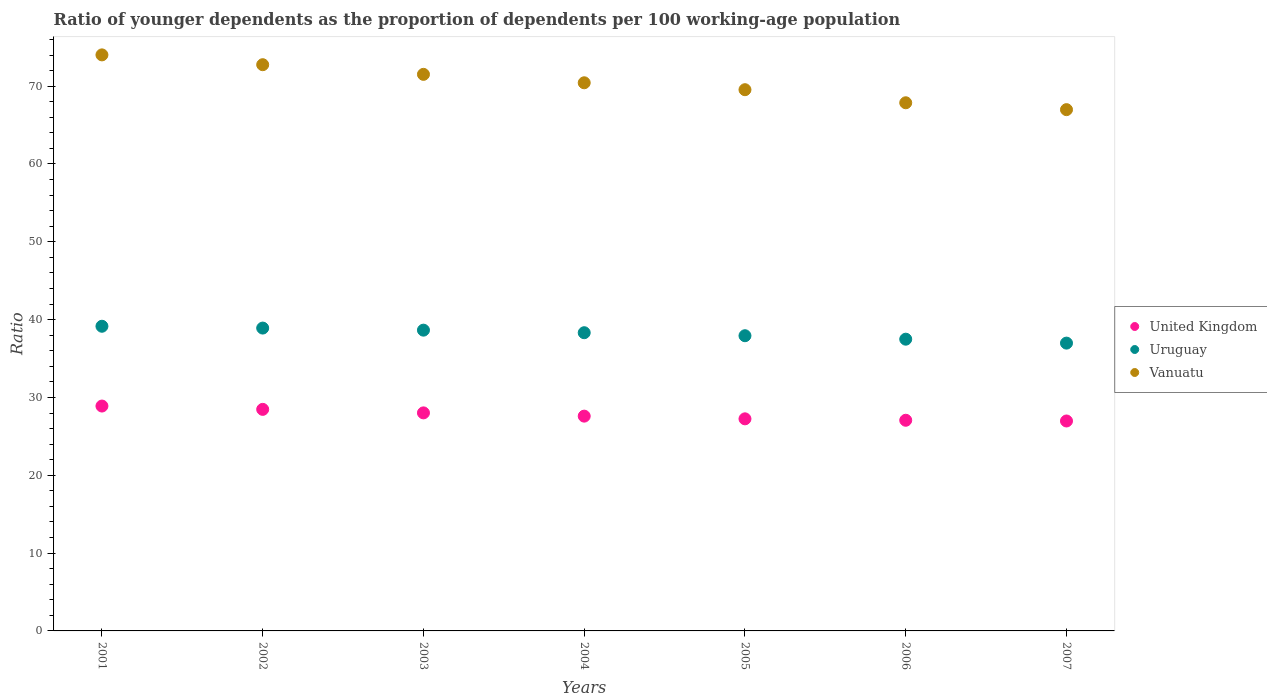How many different coloured dotlines are there?
Offer a very short reply. 3. What is the age dependency ratio(young) in Vanuatu in 2007?
Make the answer very short. 66.98. Across all years, what is the maximum age dependency ratio(young) in Uruguay?
Ensure brevity in your answer.  39.15. Across all years, what is the minimum age dependency ratio(young) in United Kingdom?
Your response must be concise. 26.98. In which year was the age dependency ratio(young) in Vanuatu maximum?
Your answer should be very brief. 2001. In which year was the age dependency ratio(young) in Vanuatu minimum?
Provide a succinct answer. 2007. What is the total age dependency ratio(young) in Vanuatu in the graph?
Your response must be concise. 493.09. What is the difference between the age dependency ratio(young) in Vanuatu in 2002 and that in 2007?
Your answer should be compact. 5.77. What is the difference between the age dependency ratio(young) in Vanuatu in 2004 and the age dependency ratio(young) in Uruguay in 2003?
Make the answer very short. 31.78. What is the average age dependency ratio(young) in Uruguay per year?
Ensure brevity in your answer.  38.2. In the year 2002, what is the difference between the age dependency ratio(young) in Uruguay and age dependency ratio(young) in Vanuatu?
Make the answer very short. -33.84. In how many years, is the age dependency ratio(young) in Uruguay greater than 32?
Offer a very short reply. 7. What is the ratio of the age dependency ratio(young) in Vanuatu in 2004 to that in 2007?
Make the answer very short. 1.05. Is the age dependency ratio(young) in United Kingdom in 2006 less than that in 2007?
Keep it short and to the point. No. What is the difference between the highest and the second highest age dependency ratio(young) in Uruguay?
Your answer should be very brief. 0.23. What is the difference between the highest and the lowest age dependency ratio(young) in Vanuatu?
Offer a terse response. 7.04. Does the age dependency ratio(young) in Uruguay monotonically increase over the years?
Keep it short and to the point. No. Is the age dependency ratio(young) in Vanuatu strictly greater than the age dependency ratio(young) in Uruguay over the years?
Your answer should be very brief. Yes. What is the difference between two consecutive major ticks on the Y-axis?
Make the answer very short. 10. Does the graph contain grids?
Offer a terse response. No. How are the legend labels stacked?
Ensure brevity in your answer.  Vertical. What is the title of the graph?
Provide a succinct answer. Ratio of younger dependents as the proportion of dependents per 100 working-age population. What is the label or title of the Y-axis?
Keep it short and to the point. Ratio. What is the Ratio in United Kingdom in 2001?
Give a very brief answer. 28.89. What is the Ratio in Uruguay in 2001?
Provide a short and direct response. 39.15. What is the Ratio in Vanuatu in 2001?
Provide a short and direct response. 74.02. What is the Ratio of United Kingdom in 2002?
Make the answer very short. 28.47. What is the Ratio of Uruguay in 2002?
Keep it short and to the point. 38.91. What is the Ratio of Vanuatu in 2002?
Your answer should be very brief. 72.75. What is the Ratio of United Kingdom in 2003?
Ensure brevity in your answer.  28.02. What is the Ratio of Uruguay in 2003?
Provide a succinct answer. 38.65. What is the Ratio in Vanuatu in 2003?
Provide a succinct answer. 71.51. What is the Ratio in United Kingdom in 2004?
Provide a succinct answer. 27.6. What is the Ratio of Uruguay in 2004?
Ensure brevity in your answer.  38.32. What is the Ratio of Vanuatu in 2004?
Provide a short and direct response. 70.43. What is the Ratio in United Kingdom in 2005?
Provide a succinct answer. 27.25. What is the Ratio of Uruguay in 2005?
Your answer should be very brief. 37.93. What is the Ratio in Vanuatu in 2005?
Offer a terse response. 69.54. What is the Ratio in United Kingdom in 2006?
Make the answer very short. 27.07. What is the Ratio in Uruguay in 2006?
Your answer should be very brief. 37.49. What is the Ratio of Vanuatu in 2006?
Provide a succinct answer. 67.86. What is the Ratio in United Kingdom in 2007?
Provide a succinct answer. 26.98. What is the Ratio in Uruguay in 2007?
Your response must be concise. 36.98. What is the Ratio in Vanuatu in 2007?
Your response must be concise. 66.98. Across all years, what is the maximum Ratio of United Kingdom?
Keep it short and to the point. 28.89. Across all years, what is the maximum Ratio in Uruguay?
Make the answer very short. 39.15. Across all years, what is the maximum Ratio of Vanuatu?
Provide a succinct answer. 74.02. Across all years, what is the minimum Ratio in United Kingdom?
Offer a terse response. 26.98. Across all years, what is the minimum Ratio in Uruguay?
Make the answer very short. 36.98. Across all years, what is the minimum Ratio in Vanuatu?
Your response must be concise. 66.98. What is the total Ratio in United Kingdom in the graph?
Give a very brief answer. 194.27. What is the total Ratio in Uruguay in the graph?
Offer a very short reply. 267.42. What is the total Ratio in Vanuatu in the graph?
Offer a terse response. 493.09. What is the difference between the Ratio of United Kingdom in 2001 and that in 2002?
Your answer should be compact. 0.43. What is the difference between the Ratio in Uruguay in 2001 and that in 2002?
Your response must be concise. 0.23. What is the difference between the Ratio in Vanuatu in 2001 and that in 2002?
Offer a terse response. 1.26. What is the difference between the Ratio of United Kingdom in 2001 and that in 2003?
Give a very brief answer. 0.88. What is the difference between the Ratio of Uruguay in 2001 and that in 2003?
Ensure brevity in your answer.  0.5. What is the difference between the Ratio in Vanuatu in 2001 and that in 2003?
Provide a succinct answer. 2.5. What is the difference between the Ratio of United Kingdom in 2001 and that in 2004?
Your answer should be very brief. 1.3. What is the difference between the Ratio in Uruguay in 2001 and that in 2004?
Your response must be concise. 0.83. What is the difference between the Ratio of Vanuatu in 2001 and that in 2004?
Ensure brevity in your answer.  3.59. What is the difference between the Ratio of United Kingdom in 2001 and that in 2005?
Make the answer very short. 1.64. What is the difference between the Ratio in Uruguay in 2001 and that in 2005?
Make the answer very short. 1.22. What is the difference between the Ratio of Vanuatu in 2001 and that in 2005?
Your response must be concise. 4.47. What is the difference between the Ratio in United Kingdom in 2001 and that in 2006?
Keep it short and to the point. 1.83. What is the difference between the Ratio of Uruguay in 2001 and that in 2006?
Your response must be concise. 1.66. What is the difference between the Ratio in Vanuatu in 2001 and that in 2006?
Ensure brevity in your answer.  6.15. What is the difference between the Ratio in United Kingdom in 2001 and that in 2007?
Offer a terse response. 1.92. What is the difference between the Ratio of Uruguay in 2001 and that in 2007?
Your answer should be compact. 2.17. What is the difference between the Ratio of Vanuatu in 2001 and that in 2007?
Your answer should be compact. 7.04. What is the difference between the Ratio in United Kingdom in 2002 and that in 2003?
Ensure brevity in your answer.  0.45. What is the difference between the Ratio in Uruguay in 2002 and that in 2003?
Your answer should be compact. 0.27. What is the difference between the Ratio of Vanuatu in 2002 and that in 2003?
Your response must be concise. 1.24. What is the difference between the Ratio in United Kingdom in 2002 and that in 2004?
Give a very brief answer. 0.87. What is the difference between the Ratio of Uruguay in 2002 and that in 2004?
Give a very brief answer. 0.6. What is the difference between the Ratio in Vanuatu in 2002 and that in 2004?
Give a very brief answer. 2.32. What is the difference between the Ratio of United Kingdom in 2002 and that in 2005?
Your answer should be compact. 1.22. What is the difference between the Ratio of Uruguay in 2002 and that in 2005?
Your response must be concise. 0.98. What is the difference between the Ratio in Vanuatu in 2002 and that in 2005?
Ensure brevity in your answer.  3.21. What is the difference between the Ratio of United Kingdom in 2002 and that in 2006?
Provide a succinct answer. 1.4. What is the difference between the Ratio of Uruguay in 2002 and that in 2006?
Give a very brief answer. 1.43. What is the difference between the Ratio of Vanuatu in 2002 and that in 2006?
Offer a very short reply. 4.89. What is the difference between the Ratio of United Kingdom in 2002 and that in 2007?
Ensure brevity in your answer.  1.49. What is the difference between the Ratio of Uruguay in 2002 and that in 2007?
Provide a short and direct response. 1.93. What is the difference between the Ratio of Vanuatu in 2002 and that in 2007?
Keep it short and to the point. 5.77. What is the difference between the Ratio in United Kingdom in 2003 and that in 2004?
Provide a succinct answer. 0.42. What is the difference between the Ratio of Uruguay in 2003 and that in 2004?
Offer a very short reply. 0.33. What is the difference between the Ratio of Vanuatu in 2003 and that in 2004?
Your answer should be compact. 1.08. What is the difference between the Ratio of United Kingdom in 2003 and that in 2005?
Provide a succinct answer. 0.77. What is the difference between the Ratio of Uruguay in 2003 and that in 2005?
Provide a short and direct response. 0.72. What is the difference between the Ratio of Vanuatu in 2003 and that in 2005?
Offer a very short reply. 1.97. What is the difference between the Ratio in United Kingdom in 2003 and that in 2006?
Keep it short and to the point. 0.95. What is the difference between the Ratio in Uruguay in 2003 and that in 2006?
Give a very brief answer. 1.16. What is the difference between the Ratio of Vanuatu in 2003 and that in 2006?
Provide a succinct answer. 3.65. What is the difference between the Ratio of United Kingdom in 2003 and that in 2007?
Provide a succinct answer. 1.04. What is the difference between the Ratio of Uruguay in 2003 and that in 2007?
Your answer should be compact. 1.67. What is the difference between the Ratio of Vanuatu in 2003 and that in 2007?
Your response must be concise. 4.53. What is the difference between the Ratio of United Kingdom in 2004 and that in 2005?
Offer a terse response. 0.35. What is the difference between the Ratio in Uruguay in 2004 and that in 2005?
Offer a very short reply. 0.39. What is the difference between the Ratio of Vanuatu in 2004 and that in 2005?
Your response must be concise. 0.89. What is the difference between the Ratio in United Kingdom in 2004 and that in 2006?
Give a very brief answer. 0.53. What is the difference between the Ratio in Uruguay in 2004 and that in 2006?
Keep it short and to the point. 0.83. What is the difference between the Ratio of Vanuatu in 2004 and that in 2006?
Provide a succinct answer. 2.57. What is the difference between the Ratio in United Kingdom in 2004 and that in 2007?
Your answer should be compact. 0.62. What is the difference between the Ratio in Uruguay in 2004 and that in 2007?
Offer a very short reply. 1.34. What is the difference between the Ratio in Vanuatu in 2004 and that in 2007?
Ensure brevity in your answer.  3.45. What is the difference between the Ratio of United Kingdom in 2005 and that in 2006?
Offer a very short reply. 0.18. What is the difference between the Ratio of Uruguay in 2005 and that in 2006?
Keep it short and to the point. 0.45. What is the difference between the Ratio of Vanuatu in 2005 and that in 2006?
Give a very brief answer. 1.68. What is the difference between the Ratio in United Kingdom in 2005 and that in 2007?
Your response must be concise. 0.28. What is the difference between the Ratio of Uruguay in 2005 and that in 2007?
Your response must be concise. 0.95. What is the difference between the Ratio in Vanuatu in 2005 and that in 2007?
Your response must be concise. 2.56. What is the difference between the Ratio in United Kingdom in 2006 and that in 2007?
Ensure brevity in your answer.  0.09. What is the difference between the Ratio in Uruguay in 2006 and that in 2007?
Provide a short and direct response. 0.51. What is the difference between the Ratio of Vanuatu in 2006 and that in 2007?
Provide a succinct answer. 0.88. What is the difference between the Ratio of United Kingdom in 2001 and the Ratio of Uruguay in 2002?
Your answer should be very brief. -10.02. What is the difference between the Ratio of United Kingdom in 2001 and the Ratio of Vanuatu in 2002?
Offer a terse response. -43.86. What is the difference between the Ratio in Uruguay in 2001 and the Ratio in Vanuatu in 2002?
Your answer should be very brief. -33.61. What is the difference between the Ratio in United Kingdom in 2001 and the Ratio in Uruguay in 2003?
Provide a short and direct response. -9.75. What is the difference between the Ratio in United Kingdom in 2001 and the Ratio in Vanuatu in 2003?
Offer a very short reply. -42.62. What is the difference between the Ratio of Uruguay in 2001 and the Ratio of Vanuatu in 2003?
Offer a terse response. -32.37. What is the difference between the Ratio in United Kingdom in 2001 and the Ratio in Uruguay in 2004?
Offer a very short reply. -9.42. What is the difference between the Ratio in United Kingdom in 2001 and the Ratio in Vanuatu in 2004?
Your response must be concise. -41.54. What is the difference between the Ratio in Uruguay in 2001 and the Ratio in Vanuatu in 2004?
Make the answer very short. -31.28. What is the difference between the Ratio in United Kingdom in 2001 and the Ratio in Uruguay in 2005?
Your answer should be very brief. -9.04. What is the difference between the Ratio of United Kingdom in 2001 and the Ratio of Vanuatu in 2005?
Provide a succinct answer. -40.65. What is the difference between the Ratio of Uruguay in 2001 and the Ratio of Vanuatu in 2005?
Offer a very short reply. -30.4. What is the difference between the Ratio in United Kingdom in 2001 and the Ratio in Uruguay in 2006?
Ensure brevity in your answer.  -8.59. What is the difference between the Ratio in United Kingdom in 2001 and the Ratio in Vanuatu in 2006?
Your answer should be very brief. -38.97. What is the difference between the Ratio in Uruguay in 2001 and the Ratio in Vanuatu in 2006?
Provide a succinct answer. -28.72. What is the difference between the Ratio of United Kingdom in 2001 and the Ratio of Uruguay in 2007?
Offer a terse response. -8.09. What is the difference between the Ratio of United Kingdom in 2001 and the Ratio of Vanuatu in 2007?
Your response must be concise. -38.08. What is the difference between the Ratio in Uruguay in 2001 and the Ratio in Vanuatu in 2007?
Provide a succinct answer. -27.83. What is the difference between the Ratio in United Kingdom in 2002 and the Ratio in Uruguay in 2003?
Offer a very short reply. -10.18. What is the difference between the Ratio in United Kingdom in 2002 and the Ratio in Vanuatu in 2003?
Offer a very short reply. -43.05. What is the difference between the Ratio of Uruguay in 2002 and the Ratio of Vanuatu in 2003?
Give a very brief answer. -32.6. What is the difference between the Ratio of United Kingdom in 2002 and the Ratio of Uruguay in 2004?
Give a very brief answer. -9.85. What is the difference between the Ratio of United Kingdom in 2002 and the Ratio of Vanuatu in 2004?
Make the answer very short. -41.96. What is the difference between the Ratio in Uruguay in 2002 and the Ratio in Vanuatu in 2004?
Your answer should be very brief. -31.52. What is the difference between the Ratio in United Kingdom in 2002 and the Ratio in Uruguay in 2005?
Ensure brevity in your answer.  -9.46. What is the difference between the Ratio of United Kingdom in 2002 and the Ratio of Vanuatu in 2005?
Offer a terse response. -41.07. What is the difference between the Ratio in Uruguay in 2002 and the Ratio in Vanuatu in 2005?
Your answer should be compact. -30.63. What is the difference between the Ratio of United Kingdom in 2002 and the Ratio of Uruguay in 2006?
Offer a terse response. -9.02. What is the difference between the Ratio of United Kingdom in 2002 and the Ratio of Vanuatu in 2006?
Give a very brief answer. -39.39. What is the difference between the Ratio of Uruguay in 2002 and the Ratio of Vanuatu in 2006?
Make the answer very short. -28.95. What is the difference between the Ratio of United Kingdom in 2002 and the Ratio of Uruguay in 2007?
Offer a very short reply. -8.51. What is the difference between the Ratio in United Kingdom in 2002 and the Ratio in Vanuatu in 2007?
Your answer should be compact. -38.51. What is the difference between the Ratio in Uruguay in 2002 and the Ratio in Vanuatu in 2007?
Provide a short and direct response. -28.07. What is the difference between the Ratio in United Kingdom in 2003 and the Ratio in Uruguay in 2004?
Your answer should be very brief. -10.3. What is the difference between the Ratio in United Kingdom in 2003 and the Ratio in Vanuatu in 2004?
Make the answer very short. -42.41. What is the difference between the Ratio in Uruguay in 2003 and the Ratio in Vanuatu in 2004?
Ensure brevity in your answer.  -31.78. What is the difference between the Ratio of United Kingdom in 2003 and the Ratio of Uruguay in 2005?
Your answer should be compact. -9.91. What is the difference between the Ratio of United Kingdom in 2003 and the Ratio of Vanuatu in 2005?
Offer a very short reply. -41.53. What is the difference between the Ratio in Uruguay in 2003 and the Ratio in Vanuatu in 2005?
Offer a terse response. -30.9. What is the difference between the Ratio in United Kingdom in 2003 and the Ratio in Uruguay in 2006?
Offer a very short reply. -9.47. What is the difference between the Ratio of United Kingdom in 2003 and the Ratio of Vanuatu in 2006?
Give a very brief answer. -39.85. What is the difference between the Ratio of Uruguay in 2003 and the Ratio of Vanuatu in 2006?
Offer a terse response. -29.22. What is the difference between the Ratio in United Kingdom in 2003 and the Ratio in Uruguay in 2007?
Provide a succinct answer. -8.96. What is the difference between the Ratio in United Kingdom in 2003 and the Ratio in Vanuatu in 2007?
Give a very brief answer. -38.96. What is the difference between the Ratio in Uruguay in 2003 and the Ratio in Vanuatu in 2007?
Your answer should be compact. -28.33. What is the difference between the Ratio of United Kingdom in 2004 and the Ratio of Uruguay in 2005?
Offer a very short reply. -10.33. What is the difference between the Ratio of United Kingdom in 2004 and the Ratio of Vanuatu in 2005?
Ensure brevity in your answer.  -41.94. What is the difference between the Ratio of Uruguay in 2004 and the Ratio of Vanuatu in 2005?
Offer a very short reply. -31.23. What is the difference between the Ratio of United Kingdom in 2004 and the Ratio of Uruguay in 2006?
Ensure brevity in your answer.  -9.89. What is the difference between the Ratio of United Kingdom in 2004 and the Ratio of Vanuatu in 2006?
Provide a short and direct response. -40.26. What is the difference between the Ratio of Uruguay in 2004 and the Ratio of Vanuatu in 2006?
Offer a very short reply. -29.55. What is the difference between the Ratio in United Kingdom in 2004 and the Ratio in Uruguay in 2007?
Offer a very short reply. -9.38. What is the difference between the Ratio of United Kingdom in 2004 and the Ratio of Vanuatu in 2007?
Make the answer very short. -39.38. What is the difference between the Ratio in Uruguay in 2004 and the Ratio in Vanuatu in 2007?
Keep it short and to the point. -28.66. What is the difference between the Ratio of United Kingdom in 2005 and the Ratio of Uruguay in 2006?
Offer a very short reply. -10.23. What is the difference between the Ratio in United Kingdom in 2005 and the Ratio in Vanuatu in 2006?
Provide a short and direct response. -40.61. What is the difference between the Ratio in Uruguay in 2005 and the Ratio in Vanuatu in 2006?
Offer a terse response. -29.93. What is the difference between the Ratio of United Kingdom in 2005 and the Ratio of Uruguay in 2007?
Keep it short and to the point. -9.73. What is the difference between the Ratio in United Kingdom in 2005 and the Ratio in Vanuatu in 2007?
Provide a short and direct response. -39.73. What is the difference between the Ratio in Uruguay in 2005 and the Ratio in Vanuatu in 2007?
Your answer should be compact. -29.05. What is the difference between the Ratio of United Kingdom in 2006 and the Ratio of Uruguay in 2007?
Your answer should be compact. -9.91. What is the difference between the Ratio of United Kingdom in 2006 and the Ratio of Vanuatu in 2007?
Keep it short and to the point. -39.91. What is the difference between the Ratio of Uruguay in 2006 and the Ratio of Vanuatu in 2007?
Provide a short and direct response. -29.49. What is the average Ratio in United Kingdom per year?
Provide a short and direct response. 27.75. What is the average Ratio in Uruguay per year?
Provide a succinct answer. 38.2. What is the average Ratio of Vanuatu per year?
Your answer should be compact. 70.44. In the year 2001, what is the difference between the Ratio in United Kingdom and Ratio in Uruguay?
Your answer should be very brief. -10.25. In the year 2001, what is the difference between the Ratio of United Kingdom and Ratio of Vanuatu?
Make the answer very short. -45.12. In the year 2001, what is the difference between the Ratio in Uruguay and Ratio in Vanuatu?
Your answer should be compact. -34.87. In the year 2002, what is the difference between the Ratio in United Kingdom and Ratio in Uruguay?
Make the answer very short. -10.45. In the year 2002, what is the difference between the Ratio of United Kingdom and Ratio of Vanuatu?
Provide a short and direct response. -44.29. In the year 2002, what is the difference between the Ratio in Uruguay and Ratio in Vanuatu?
Make the answer very short. -33.84. In the year 2003, what is the difference between the Ratio of United Kingdom and Ratio of Uruguay?
Provide a succinct answer. -10.63. In the year 2003, what is the difference between the Ratio of United Kingdom and Ratio of Vanuatu?
Offer a very short reply. -43.5. In the year 2003, what is the difference between the Ratio of Uruguay and Ratio of Vanuatu?
Your response must be concise. -32.87. In the year 2004, what is the difference between the Ratio of United Kingdom and Ratio of Uruguay?
Ensure brevity in your answer.  -10.72. In the year 2004, what is the difference between the Ratio of United Kingdom and Ratio of Vanuatu?
Your answer should be compact. -42.83. In the year 2004, what is the difference between the Ratio in Uruguay and Ratio in Vanuatu?
Give a very brief answer. -32.11. In the year 2005, what is the difference between the Ratio of United Kingdom and Ratio of Uruguay?
Give a very brief answer. -10.68. In the year 2005, what is the difference between the Ratio of United Kingdom and Ratio of Vanuatu?
Provide a succinct answer. -42.29. In the year 2005, what is the difference between the Ratio in Uruguay and Ratio in Vanuatu?
Keep it short and to the point. -31.61. In the year 2006, what is the difference between the Ratio in United Kingdom and Ratio in Uruguay?
Offer a terse response. -10.42. In the year 2006, what is the difference between the Ratio in United Kingdom and Ratio in Vanuatu?
Your answer should be very brief. -40.79. In the year 2006, what is the difference between the Ratio in Uruguay and Ratio in Vanuatu?
Provide a succinct answer. -30.38. In the year 2007, what is the difference between the Ratio of United Kingdom and Ratio of Uruguay?
Keep it short and to the point. -10.01. In the year 2007, what is the difference between the Ratio in United Kingdom and Ratio in Vanuatu?
Your response must be concise. -40. In the year 2007, what is the difference between the Ratio in Uruguay and Ratio in Vanuatu?
Provide a short and direct response. -30. What is the ratio of the Ratio in Uruguay in 2001 to that in 2002?
Keep it short and to the point. 1.01. What is the ratio of the Ratio in Vanuatu in 2001 to that in 2002?
Ensure brevity in your answer.  1.02. What is the ratio of the Ratio in United Kingdom in 2001 to that in 2003?
Keep it short and to the point. 1.03. What is the ratio of the Ratio of Uruguay in 2001 to that in 2003?
Your answer should be compact. 1.01. What is the ratio of the Ratio in Vanuatu in 2001 to that in 2003?
Give a very brief answer. 1.03. What is the ratio of the Ratio of United Kingdom in 2001 to that in 2004?
Ensure brevity in your answer.  1.05. What is the ratio of the Ratio of Uruguay in 2001 to that in 2004?
Provide a short and direct response. 1.02. What is the ratio of the Ratio in Vanuatu in 2001 to that in 2004?
Ensure brevity in your answer.  1.05. What is the ratio of the Ratio in United Kingdom in 2001 to that in 2005?
Keep it short and to the point. 1.06. What is the ratio of the Ratio of Uruguay in 2001 to that in 2005?
Give a very brief answer. 1.03. What is the ratio of the Ratio in Vanuatu in 2001 to that in 2005?
Make the answer very short. 1.06. What is the ratio of the Ratio of United Kingdom in 2001 to that in 2006?
Ensure brevity in your answer.  1.07. What is the ratio of the Ratio of Uruguay in 2001 to that in 2006?
Ensure brevity in your answer.  1.04. What is the ratio of the Ratio in Vanuatu in 2001 to that in 2006?
Your response must be concise. 1.09. What is the ratio of the Ratio of United Kingdom in 2001 to that in 2007?
Your response must be concise. 1.07. What is the ratio of the Ratio of Uruguay in 2001 to that in 2007?
Ensure brevity in your answer.  1.06. What is the ratio of the Ratio of Vanuatu in 2001 to that in 2007?
Provide a succinct answer. 1.11. What is the ratio of the Ratio in United Kingdom in 2002 to that in 2003?
Your answer should be compact. 1.02. What is the ratio of the Ratio in Uruguay in 2002 to that in 2003?
Provide a short and direct response. 1.01. What is the ratio of the Ratio in Vanuatu in 2002 to that in 2003?
Your response must be concise. 1.02. What is the ratio of the Ratio in United Kingdom in 2002 to that in 2004?
Ensure brevity in your answer.  1.03. What is the ratio of the Ratio of Uruguay in 2002 to that in 2004?
Your answer should be very brief. 1.02. What is the ratio of the Ratio in Vanuatu in 2002 to that in 2004?
Make the answer very short. 1.03. What is the ratio of the Ratio of United Kingdom in 2002 to that in 2005?
Give a very brief answer. 1.04. What is the ratio of the Ratio of Uruguay in 2002 to that in 2005?
Your answer should be compact. 1.03. What is the ratio of the Ratio of Vanuatu in 2002 to that in 2005?
Make the answer very short. 1.05. What is the ratio of the Ratio of United Kingdom in 2002 to that in 2006?
Give a very brief answer. 1.05. What is the ratio of the Ratio in Uruguay in 2002 to that in 2006?
Your answer should be very brief. 1.04. What is the ratio of the Ratio of Vanuatu in 2002 to that in 2006?
Ensure brevity in your answer.  1.07. What is the ratio of the Ratio in United Kingdom in 2002 to that in 2007?
Offer a very short reply. 1.06. What is the ratio of the Ratio in Uruguay in 2002 to that in 2007?
Provide a succinct answer. 1.05. What is the ratio of the Ratio of Vanuatu in 2002 to that in 2007?
Your answer should be very brief. 1.09. What is the ratio of the Ratio in United Kingdom in 2003 to that in 2004?
Ensure brevity in your answer.  1.02. What is the ratio of the Ratio of Uruguay in 2003 to that in 2004?
Provide a short and direct response. 1.01. What is the ratio of the Ratio of Vanuatu in 2003 to that in 2004?
Make the answer very short. 1.02. What is the ratio of the Ratio in United Kingdom in 2003 to that in 2005?
Keep it short and to the point. 1.03. What is the ratio of the Ratio in Uruguay in 2003 to that in 2005?
Provide a short and direct response. 1.02. What is the ratio of the Ratio of Vanuatu in 2003 to that in 2005?
Make the answer very short. 1.03. What is the ratio of the Ratio in United Kingdom in 2003 to that in 2006?
Ensure brevity in your answer.  1.03. What is the ratio of the Ratio of Uruguay in 2003 to that in 2006?
Make the answer very short. 1.03. What is the ratio of the Ratio in Vanuatu in 2003 to that in 2006?
Your response must be concise. 1.05. What is the ratio of the Ratio in United Kingdom in 2003 to that in 2007?
Provide a short and direct response. 1.04. What is the ratio of the Ratio in Uruguay in 2003 to that in 2007?
Your answer should be very brief. 1.04. What is the ratio of the Ratio of Vanuatu in 2003 to that in 2007?
Keep it short and to the point. 1.07. What is the ratio of the Ratio of United Kingdom in 2004 to that in 2005?
Offer a very short reply. 1.01. What is the ratio of the Ratio of Uruguay in 2004 to that in 2005?
Your answer should be very brief. 1.01. What is the ratio of the Ratio in Vanuatu in 2004 to that in 2005?
Keep it short and to the point. 1.01. What is the ratio of the Ratio in United Kingdom in 2004 to that in 2006?
Offer a very short reply. 1.02. What is the ratio of the Ratio in Uruguay in 2004 to that in 2006?
Keep it short and to the point. 1.02. What is the ratio of the Ratio in Vanuatu in 2004 to that in 2006?
Give a very brief answer. 1.04. What is the ratio of the Ratio in United Kingdom in 2004 to that in 2007?
Your response must be concise. 1.02. What is the ratio of the Ratio of Uruguay in 2004 to that in 2007?
Your answer should be compact. 1.04. What is the ratio of the Ratio of Vanuatu in 2004 to that in 2007?
Your answer should be very brief. 1.05. What is the ratio of the Ratio of United Kingdom in 2005 to that in 2006?
Keep it short and to the point. 1.01. What is the ratio of the Ratio in Uruguay in 2005 to that in 2006?
Provide a succinct answer. 1.01. What is the ratio of the Ratio in Vanuatu in 2005 to that in 2006?
Your answer should be very brief. 1.02. What is the ratio of the Ratio of United Kingdom in 2005 to that in 2007?
Your response must be concise. 1.01. What is the ratio of the Ratio of Uruguay in 2005 to that in 2007?
Offer a terse response. 1.03. What is the ratio of the Ratio in Vanuatu in 2005 to that in 2007?
Provide a short and direct response. 1.04. What is the ratio of the Ratio in Uruguay in 2006 to that in 2007?
Ensure brevity in your answer.  1.01. What is the ratio of the Ratio in Vanuatu in 2006 to that in 2007?
Make the answer very short. 1.01. What is the difference between the highest and the second highest Ratio of United Kingdom?
Provide a succinct answer. 0.43. What is the difference between the highest and the second highest Ratio of Uruguay?
Offer a terse response. 0.23. What is the difference between the highest and the second highest Ratio in Vanuatu?
Provide a short and direct response. 1.26. What is the difference between the highest and the lowest Ratio of United Kingdom?
Make the answer very short. 1.92. What is the difference between the highest and the lowest Ratio of Uruguay?
Offer a terse response. 2.17. What is the difference between the highest and the lowest Ratio of Vanuatu?
Your response must be concise. 7.04. 